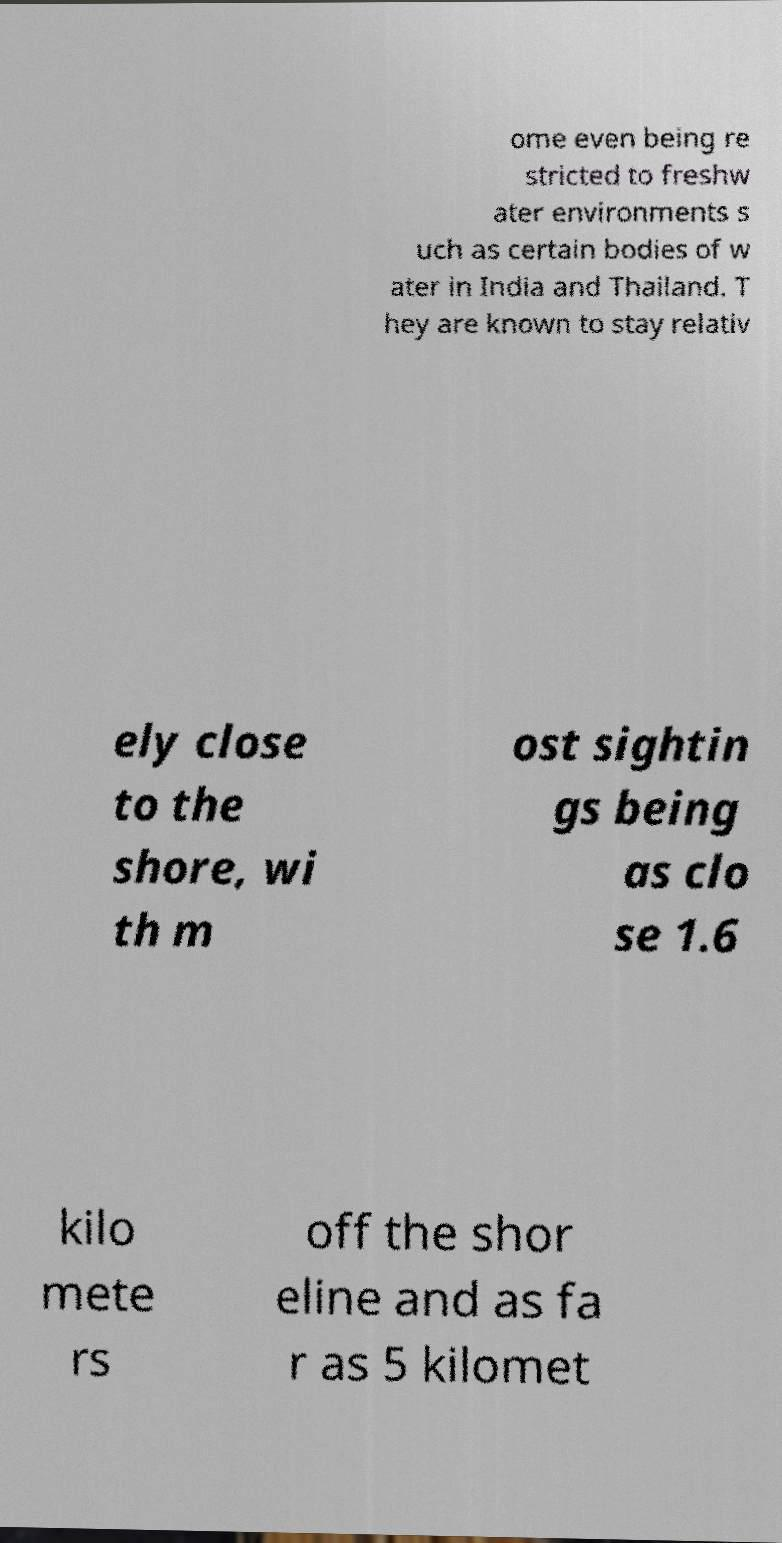Please identify and transcribe the text found in this image. ome even being re stricted to freshw ater environments s uch as certain bodies of w ater in India and Thailand. T hey are known to stay relativ ely close to the shore, wi th m ost sightin gs being as clo se 1.6 kilo mete rs off the shor eline and as fa r as 5 kilomet 